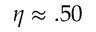<formula> <loc_0><loc_0><loc_500><loc_500>\eta \approx . 5 0</formula> 